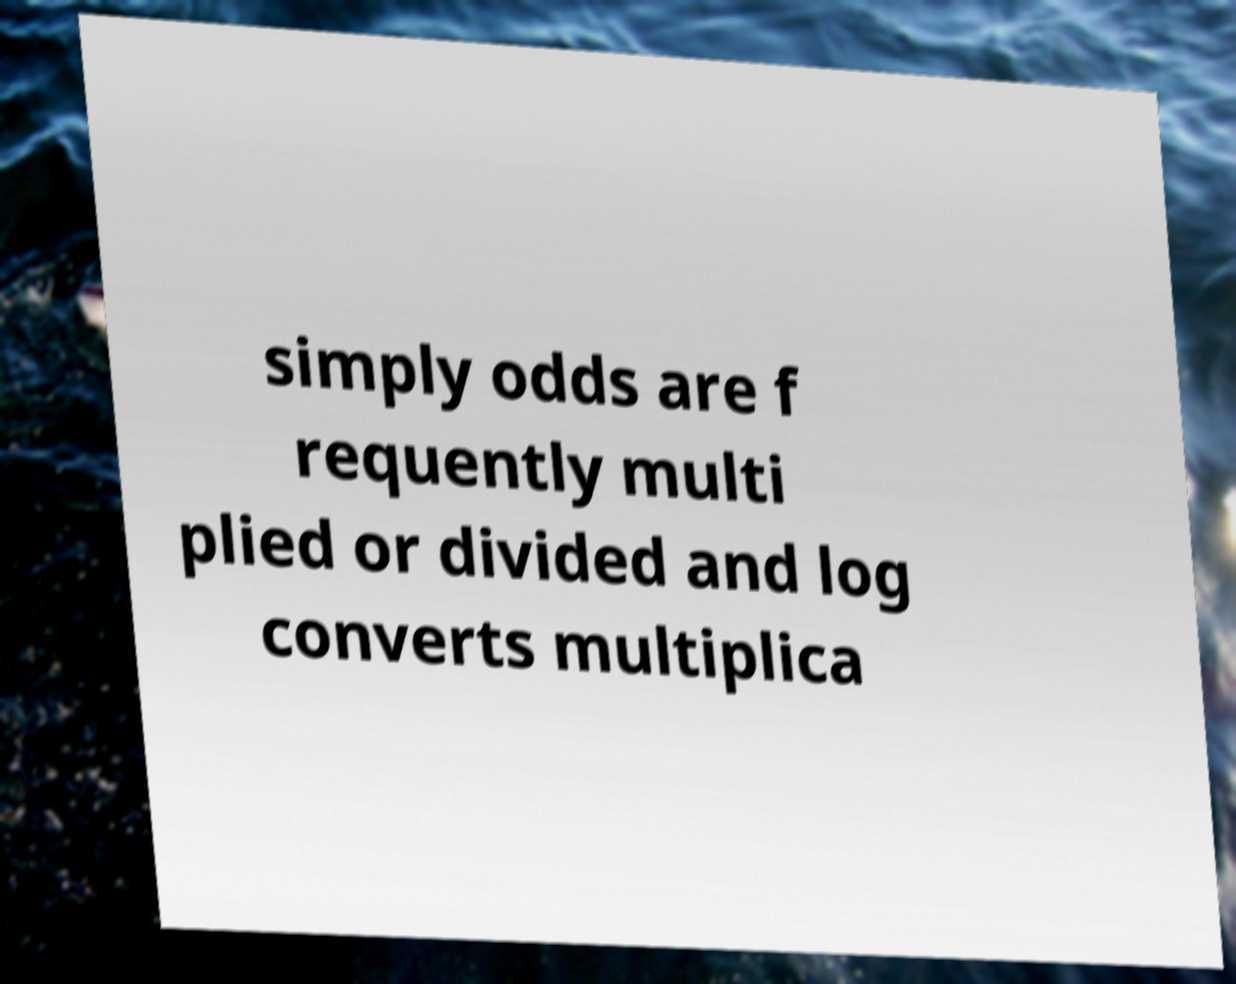Could you extract and type out the text from this image? simply odds are f requently multi plied or divided and log converts multiplica 